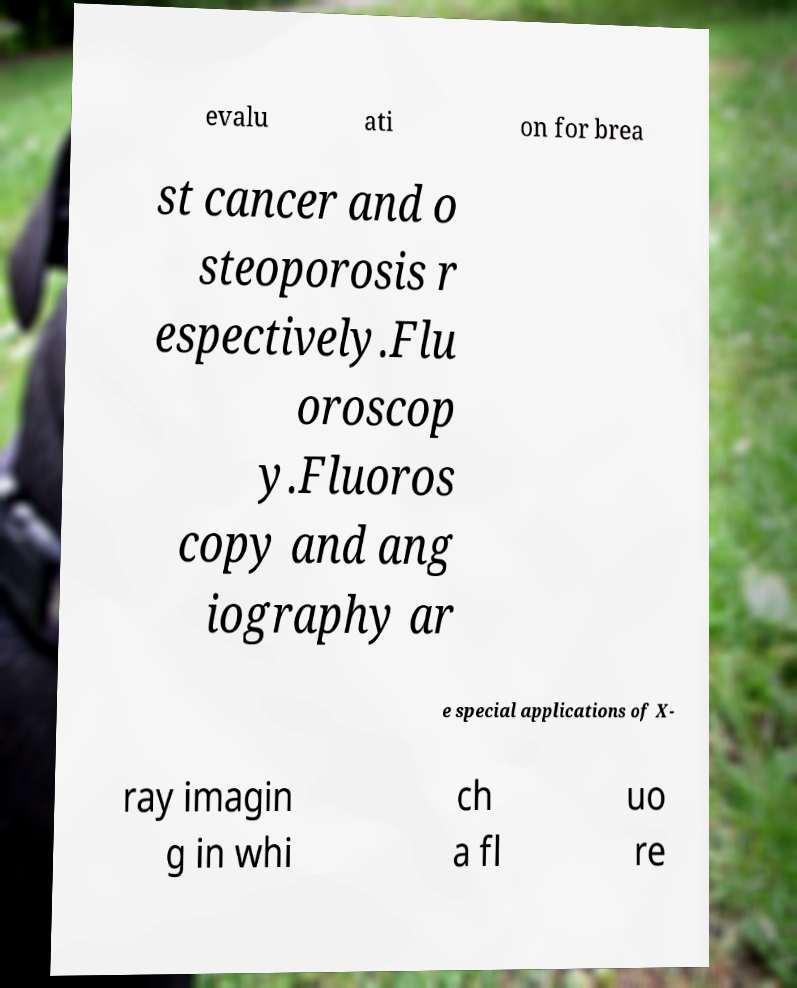There's text embedded in this image that I need extracted. Can you transcribe it verbatim? evalu ati on for brea st cancer and o steoporosis r espectively.Flu oroscop y.Fluoros copy and ang iography ar e special applications of X- ray imagin g in whi ch a fl uo re 